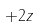<formula> <loc_0><loc_0><loc_500><loc_500>+ 2 z</formula> 